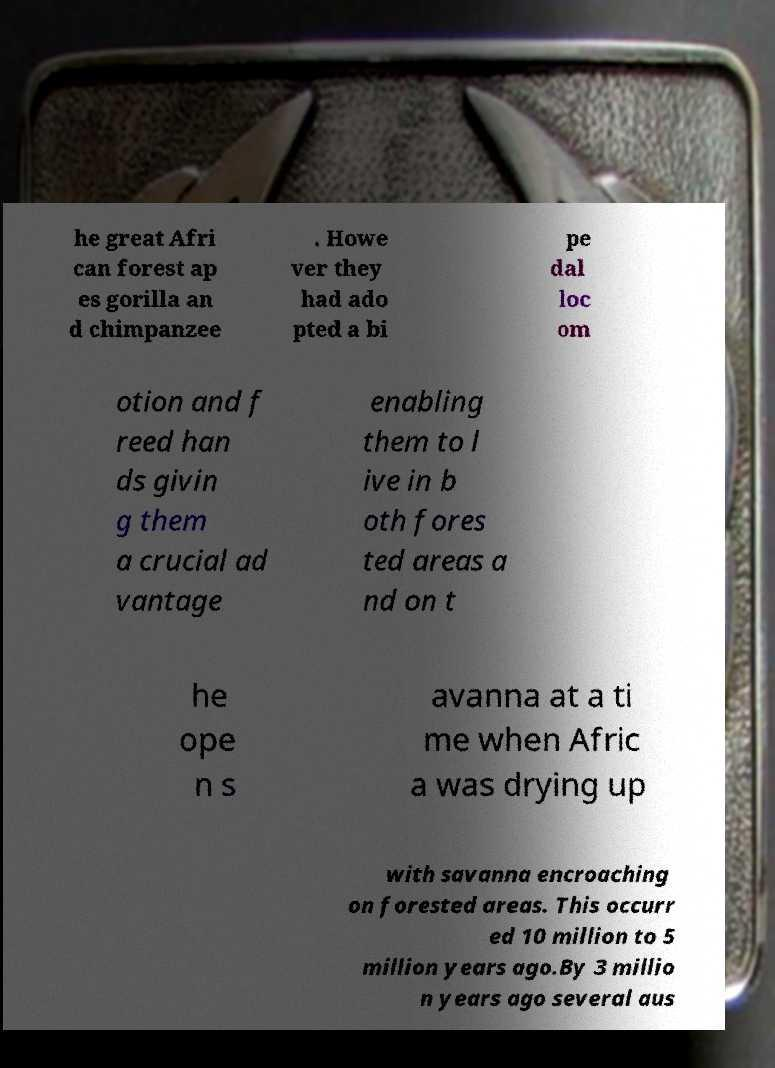Could you assist in decoding the text presented in this image and type it out clearly? he great Afri can forest ap es gorilla an d chimpanzee . Howe ver they had ado pted a bi pe dal loc om otion and f reed han ds givin g them a crucial ad vantage enabling them to l ive in b oth fores ted areas a nd on t he ope n s avanna at a ti me when Afric a was drying up with savanna encroaching on forested areas. This occurr ed 10 million to 5 million years ago.By 3 millio n years ago several aus 